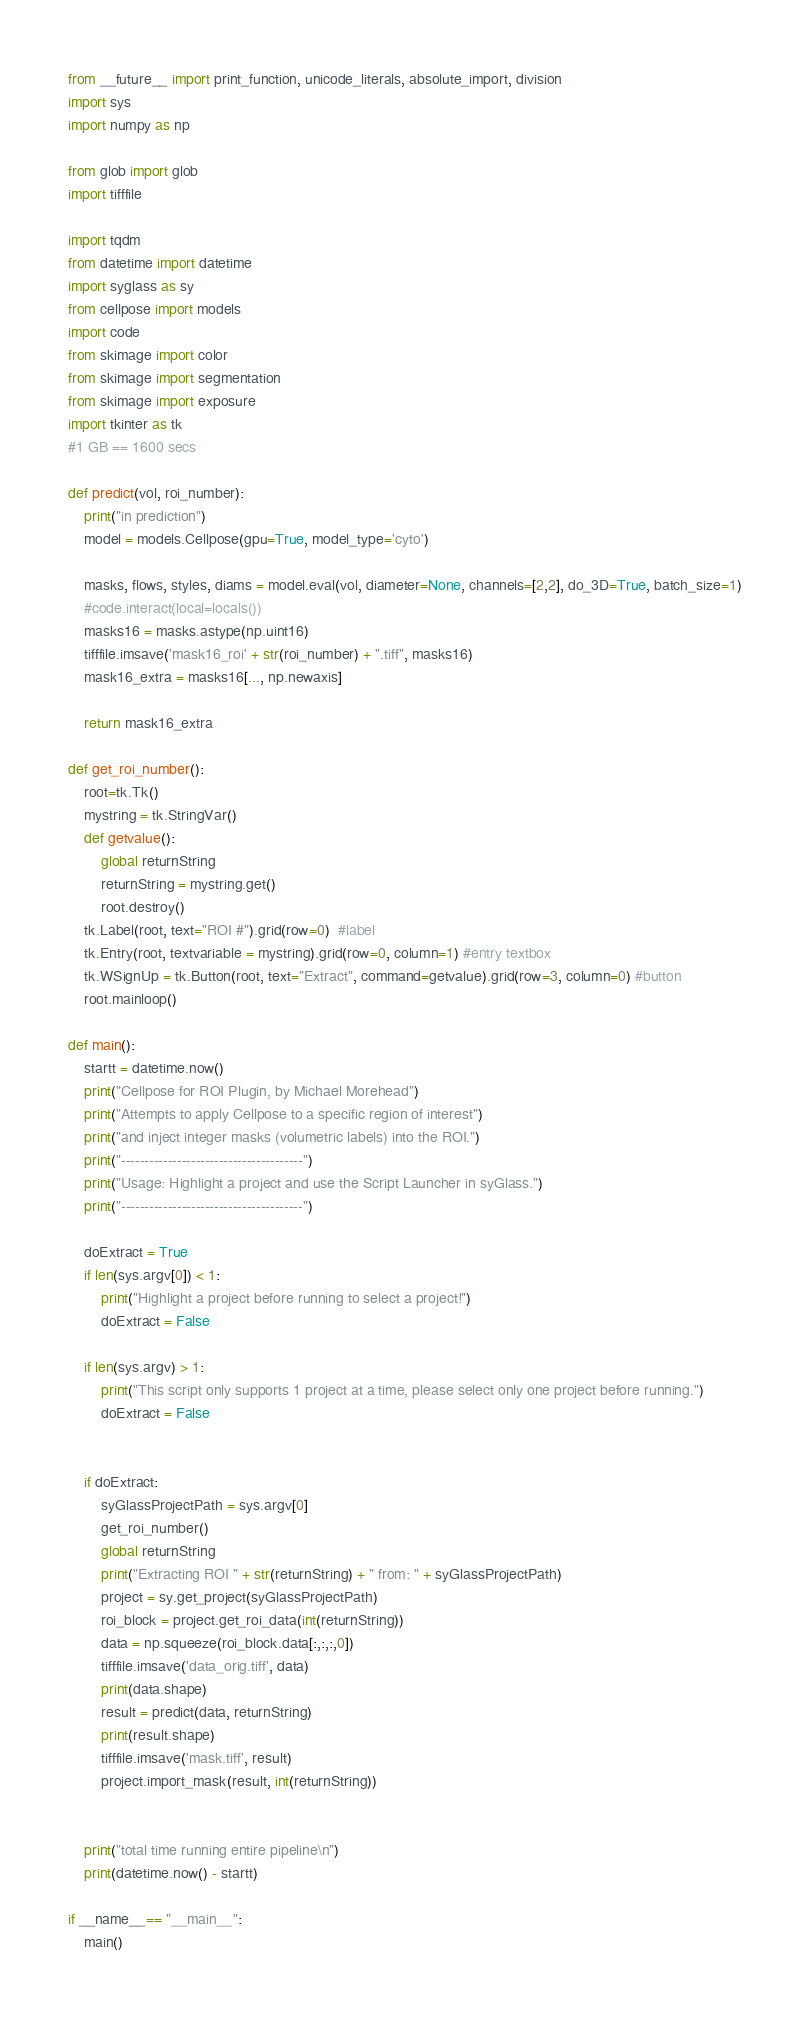Convert code to text. <code><loc_0><loc_0><loc_500><loc_500><_Python_>from __future__ import print_function, unicode_literals, absolute_import, division
import sys
import numpy as np

from glob import glob
import tifffile

import tqdm
from datetime import datetime
import syglass as sy
from cellpose import models
import code
from skimage import color 
from skimage import segmentation
from skimage import exposure
import tkinter as tk
#1 GB == 1600 secs

def predict(vol, roi_number):
	print("in prediction")
	model = models.Cellpose(gpu=True, model_type='cyto')

	masks, flows, styles, diams = model.eval(vol, diameter=None, channels=[2,2], do_3D=True, batch_size=1)
	#code.interact(local=locals())
	masks16 = masks.astype(np.uint16)
	tifffile.imsave('mask16_roi' + str(roi_number) + ".tiff", masks16)
	mask16_extra = masks16[..., np.newaxis]

	return mask16_extra
	
def get_roi_number():
	root=tk.Tk()
	mystring = tk.StringVar()
	def getvalue():
		global returnString 
		returnString = mystring.get()
		root.destroy()
	tk.Label(root, text="ROI #").grid(row=0)  #label
	tk.Entry(root, textvariable = mystring).grid(row=0, column=1) #entry textbox
	tk.WSignUp = tk.Button(root, text="Extract", command=getvalue).grid(row=3, column=0) #button
	root.mainloop()

def main():
	startt = datetime.now()
	print("Cellpose for ROI Plugin, by Michael Morehead")
	print("Attempts to apply Cellpose to a specific region of interest")
	print("and inject integer masks (volumetric labels) into the ROI.")
	print("---------------------------------------")
	print("Usage: Highlight a project and use the Script Launcher in syGlass.")
	print("---------------------------------------")
	
	doExtract = True
	if len(sys.argv[0]) < 1:
		print("Highlight a project before running to select a project!")
		doExtract = False
	
	if len(sys.argv) > 1:
		print("This script only supports 1 project at a time, please select only one project before running.")
		doExtract = False


	if doExtract:
		syGlassProjectPath = sys.argv[0]
		get_roi_number()
		global returnString
		print("Extracting ROI " + str(returnString) + " from: " + syGlassProjectPath)
		project = sy.get_project(syGlassProjectPath)
		roi_block = project.get_roi_data(int(returnString))
		data = np.squeeze(roi_block.data[:,:,:,0])
		tifffile.imsave('data_orig.tiff', data)
		print(data.shape)
		result = predict(data, returnString)
		print(result.shape)
		tifffile.imsave('mask.tiff', result)
		project.import_mask(result, int(returnString))
		
	
	print("total time running entire pipeline\n")
	print(datetime.now() - startt)

if __name__== "__main__":
	main() 

</code> 